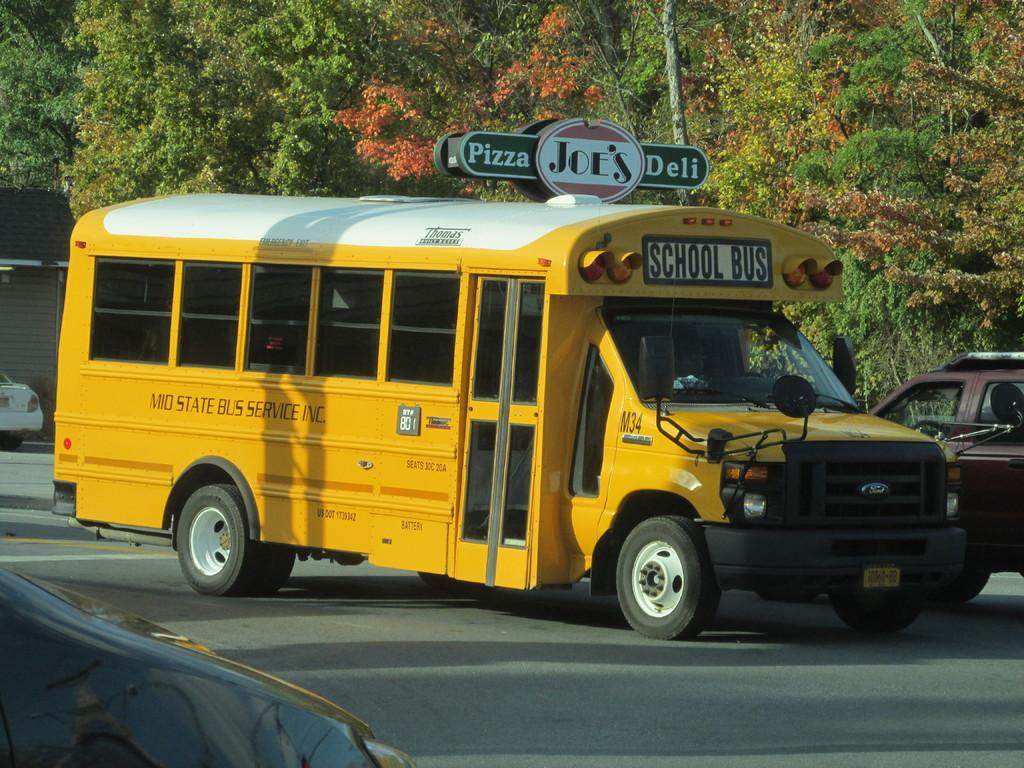What can be seen on the road in the image? There are vehicles on the road in the image. What else is visible in the image besides the vehicles? There are objects visible in the image. What type of natural scenery can be seen in the background of the image? There are trees in the background of the image. What type of mask is being worn by the tree in the image? There are no masks present in the image, and trees do not wear masks. 